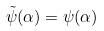<formula> <loc_0><loc_0><loc_500><loc_500>\tilde { \psi } ( \alpha ) = \psi ( \alpha )</formula> 